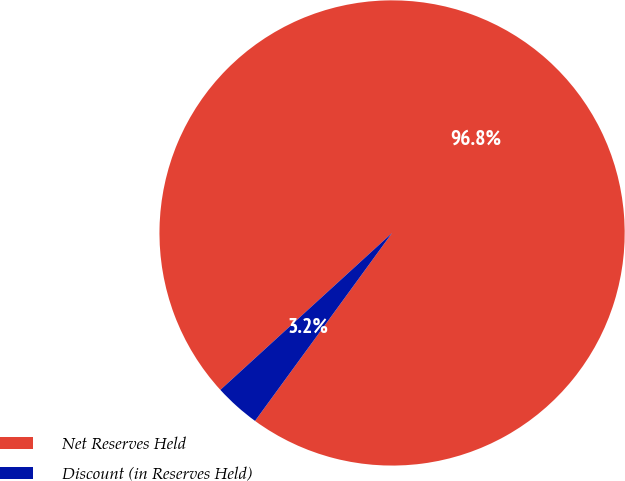Convert chart. <chart><loc_0><loc_0><loc_500><loc_500><pie_chart><fcel>Net Reserves Held<fcel>Discount (in Reserves Held)<nl><fcel>96.81%<fcel>3.19%<nl></chart> 